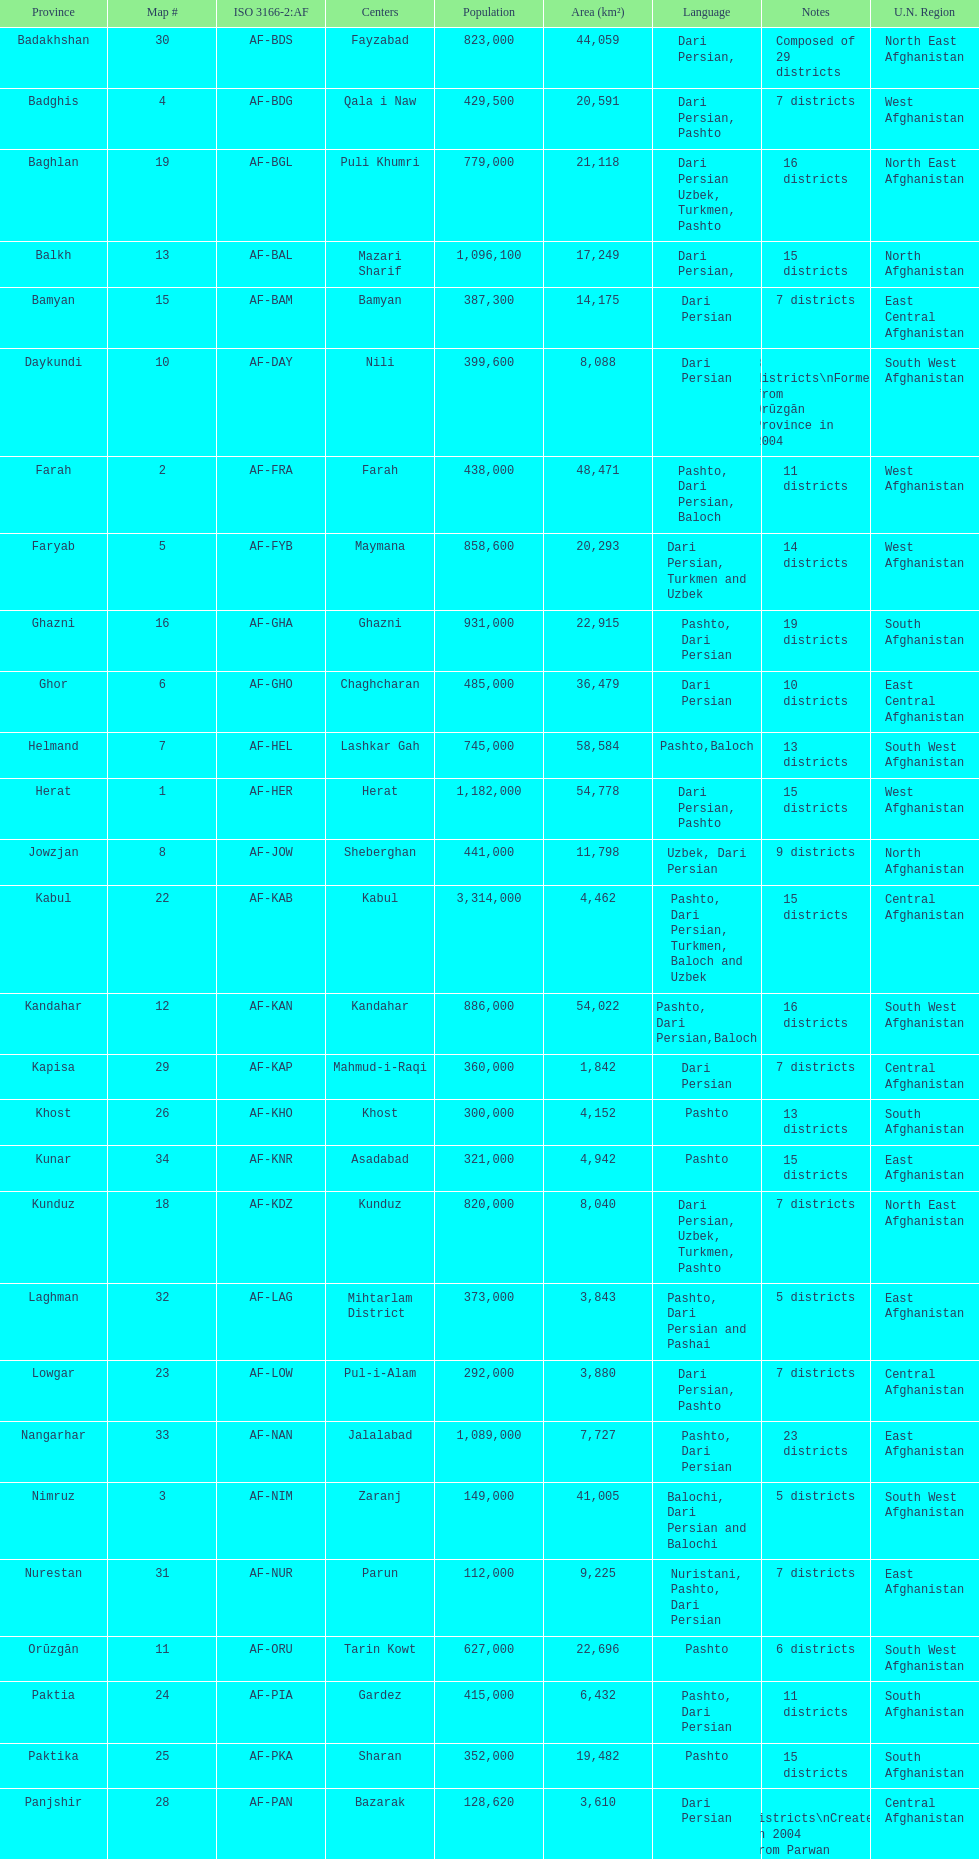How many districts exist within the province of kunduz? 7. 